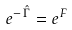<formula> <loc_0><loc_0><loc_500><loc_500>e ^ { - \, { \hat { \Gamma } } } = e ^ { F }</formula> 